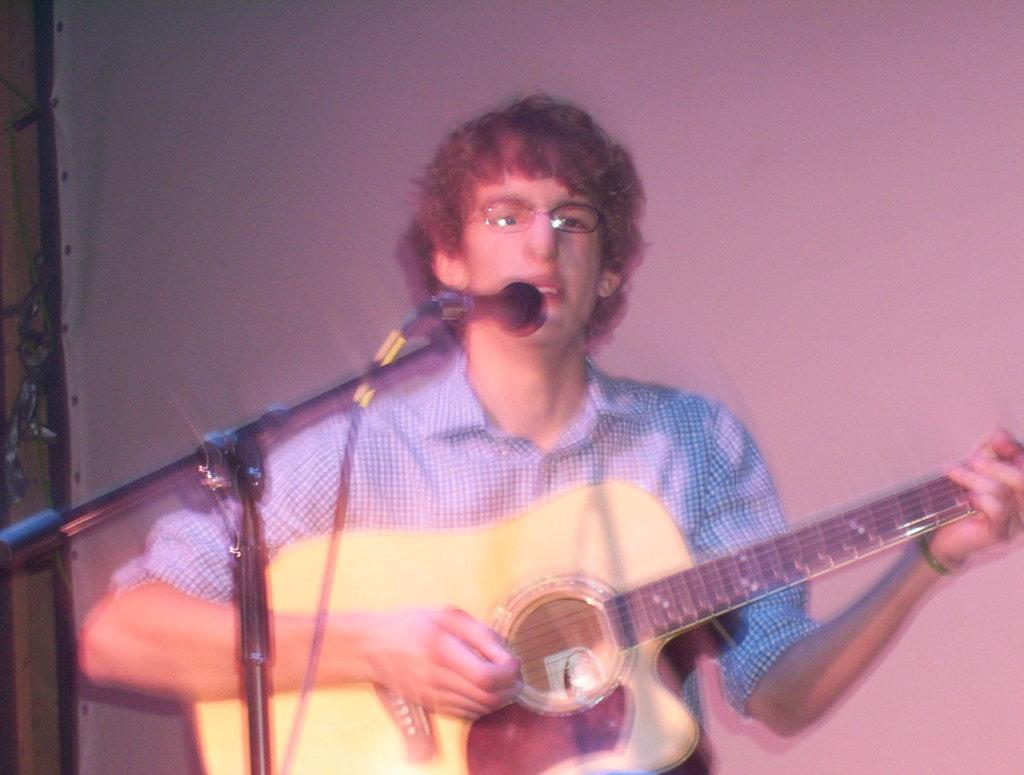What is the man in the image doing? The man is playing a guitar and singing a song. What object is the man standing in front of? The man is in front of a microphone. What instrument is the man playing in the image? The man is playing a guitar. What type of desk is visible in the image? There is no desk present in the image. Can you see any sails in the image? There are no sails present in the image. 